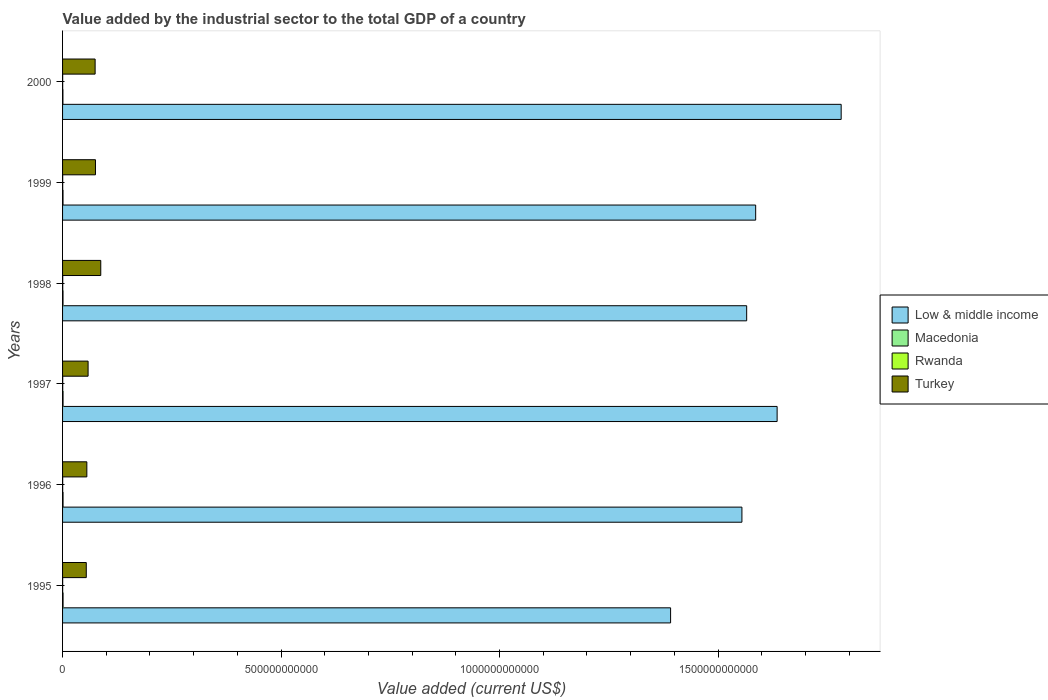Are the number of bars on each tick of the Y-axis equal?
Provide a short and direct response. Yes. In how many cases, is the number of bars for a given year not equal to the number of legend labels?
Your answer should be very brief. 0. What is the value added by the industrial sector to the total GDP in Turkey in 1999?
Provide a succinct answer. 7.53e+1. Across all years, what is the maximum value added by the industrial sector to the total GDP in Macedonia?
Your answer should be very brief. 1.13e+09. Across all years, what is the minimum value added by the industrial sector to the total GDP in Macedonia?
Offer a very short reply. 8.08e+08. In which year was the value added by the industrial sector to the total GDP in Turkey maximum?
Give a very brief answer. 1998. In which year was the value added by the industrial sector to the total GDP in Macedonia minimum?
Ensure brevity in your answer.  2000. What is the total value added by the industrial sector to the total GDP in Low & middle income in the graph?
Ensure brevity in your answer.  9.52e+12. What is the difference between the value added by the industrial sector to the total GDP in Low & middle income in 1998 and that in 2000?
Make the answer very short. -2.16e+11. What is the difference between the value added by the industrial sector to the total GDP in Rwanda in 1998 and the value added by the industrial sector to the total GDP in Low & middle income in 1999?
Your answer should be compact. -1.59e+12. What is the average value added by the industrial sector to the total GDP in Low & middle income per year?
Ensure brevity in your answer.  1.59e+12. In the year 1996, what is the difference between the value added by the industrial sector to the total GDP in Rwanda and value added by the industrial sector to the total GDP in Low & middle income?
Give a very brief answer. -1.55e+12. What is the ratio of the value added by the industrial sector to the total GDP in Low & middle income in 1996 to that in 1999?
Your response must be concise. 0.98. Is the value added by the industrial sector to the total GDP in Macedonia in 1998 less than that in 1999?
Offer a terse response. No. What is the difference between the highest and the second highest value added by the industrial sector to the total GDP in Rwanda?
Ensure brevity in your answer.  2.75e+07. What is the difference between the highest and the lowest value added by the industrial sector to the total GDP in Turkey?
Give a very brief answer. 3.31e+1. In how many years, is the value added by the industrial sector to the total GDP in Turkey greater than the average value added by the industrial sector to the total GDP in Turkey taken over all years?
Make the answer very short. 3. Is the sum of the value added by the industrial sector to the total GDP in Turkey in 1997 and 1998 greater than the maximum value added by the industrial sector to the total GDP in Macedonia across all years?
Your answer should be very brief. Yes. Is it the case that in every year, the sum of the value added by the industrial sector to the total GDP in Rwanda and value added by the industrial sector to the total GDP in Macedonia is greater than the sum of value added by the industrial sector to the total GDP in Low & middle income and value added by the industrial sector to the total GDP in Turkey?
Provide a succinct answer. No. What does the 4th bar from the top in 1996 represents?
Your response must be concise. Low & middle income. What does the 1st bar from the bottom in 1995 represents?
Offer a very short reply. Low & middle income. How many bars are there?
Give a very brief answer. 24. What is the difference between two consecutive major ticks on the X-axis?
Offer a terse response. 5.00e+11. Does the graph contain any zero values?
Make the answer very short. No. Does the graph contain grids?
Your response must be concise. No. How are the legend labels stacked?
Ensure brevity in your answer.  Vertical. What is the title of the graph?
Give a very brief answer. Value added by the industrial sector to the total GDP of a country. What is the label or title of the X-axis?
Give a very brief answer. Value added (current US$). What is the label or title of the Y-axis?
Your answer should be compact. Years. What is the Value added (current US$) in Low & middle income in 1995?
Provide a short and direct response. 1.39e+12. What is the Value added (current US$) in Macedonia in 1995?
Ensure brevity in your answer.  1.13e+09. What is the Value added (current US$) in Rwanda in 1995?
Your answer should be very brief. 2.07e+08. What is the Value added (current US$) of Turkey in 1995?
Give a very brief answer. 5.43e+1. What is the Value added (current US$) of Low & middle income in 1996?
Ensure brevity in your answer.  1.55e+12. What is the Value added (current US$) in Macedonia in 1996?
Your response must be concise. 1.11e+09. What is the Value added (current US$) in Rwanda in 1996?
Give a very brief answer. 2.50e+08. What is the Value added (current US$) of Turkey in 1996?
Give a very brief answer. 5.56e+1. What is the Value added (current US$) in Low & middle income in 1997?
Provide a short and direct response. 1.64e+12. What is the Value added (current US$) of Macedonia in 1997?
Make the answer very short. 1.11e+09. What is the Value added (current US$) of Rwanda in 1997?
Your answer should be very brief. 3.45e+08. What is the Value added (current US$) of Turkey in 1997?
Your answer should be compact. 5.84e+1. What is the Value added (current US$) in Low & middle income in 1998?
Provide a succinct answer. 1.57e+12. What is the Value added (current US$) of Macedonia in 1998?
Your answer should be compact. 1.04e+09. What is the Value added (current US$) of Rwanda in 1998?
Ensure brevity in your answer.  3.72e+08. What is the Value added (current US$) of Turkey in 1998?
Provide a short and direct response. 8.74e+1. What is the Value added (current US$) of Low & middle income in 1999?
Provide a short and direct response. 1.59e+12. What is the Value added (current US$) in Macedonia in 1999?
Ensure brevity in your answer.  1.03e+09. What is the Value added (current US$) of Rwanda in 1999?
Provide a short and direct response. 2.64e+08. What is the Value added (current US$) in Turkey in 1999?
Your response must be concise. 7.53e+1. What is the Value added (current US$) of Low & middle income in 2000?
Keep it short and to the point. 1.78e+12. What is the Value added (current US$) in Macedonia in 2000?
Keep it short and to the point. 8.08e+08. What is the Value added (current US$) of Rwanda in 2000?
Ensure brevity in your answer.  2.36e+08. What is the Value added (current US$) in Turkey in 2000?
Provide a short and direct response. 7.45e+1. Across all years, what is the maximum Value added (current US$) in Low & middle income?
Offer a very short reply. 1.78e+12. Across all years, what is the maximum Value added (current US$) of Macedonia?
Offer a very short reply. 1.13e+09. Across all years, what is the maximum Value added (current US$) in Rwanda?
Your response must be concise. 3.72e+08. Across all years, what is the maximum Value added (current US$) in Turkey?
Offer a terse response. 8.74e+1. Across all years, what is the minimum Value added (current US$) of Low & middle income?
Keep it short and to the point. 1.39e+12. Across all years, what is the minimum Value added (current US$) in Macedonia?
Keep it short and to the point. 8.08e+08. Across all years, what is the minimum Value added (current US$) in Rwanda?
Give a very brief answer. 2.07e+08. Across all years, what is the minimum Value added (current US$) of Turkey?
Offer a very short reply. 5.43e+1. What is the total Value added (current US$) in Low & middle income in the graph?
Keep it short and to the point. 9.52e+12. What is the total Value added (current US$) in Macedonia in the graph?
Provide a succinct answer. 6.22e+09. What is the total Value added (current US$) in Rwanda in the graph?
Ensure brevity in your answer.  1.67e+09. What is the total Value added (current US$) in Turkey in the graph?
Provide a short and direct response. 4.05e+11. What is the difference between the Value added (current US$) of Low & middle income in 1995 and that in 1996?
Offer a terse response. -1.63e+11. What is the difference between the Value added (current US$) of Macedonia in 1995 and that in 1996?
Provide a succinct answer. 1.90e+07. What is the difference between the Value added (current US$) in Rwanda in 1995 and that in 1996?
Give a very brief answer. -4.34e+07. What is the difference between the Value added (current US$) of Turkey in 1995 and that in 1996?
Offer a very short reply. -1.29e+09. What is the difference between the Value added (current US$) of Low & middle income in 1995 and that in 1997?
Give a very brief answer. -2.44e+11. What is the difference between the Value added (current US$) of Macedonia in 1995 and that in 1997?
Ensure brevity in your answer.  1.87e+07. What is the difference between the Value added (current US$) of Rwanda in 1995 and that in 1997?
Keep it short and to the point. -1.38e+08. What is the difference between the Value added (current US$) of Turkey in 1995 and that in 1997?
Your response must be concise. -4.16e+09. What is the difference between the Value added (current US$) of Low & middle income in 1995 and that in 1998?
Provide a short and direct response. -1.74e+11. What is the difference between the Value added (current US$) of Macedonia in 1995 and that in 1998?
Make the answer very short. 8.43e+07. What is the difference between the Value added (current US$) in Rwanda in 1995 and that in 1998?
Ensure brevity in your answer.  -1.65e+08. What is the difference between the Value added (current US$) of Turkey in 1995 and that in 1998?
Offer a very short reply. -3.31e+1. What is the difference between the Value added (current US$) of Low & middle income in 1995 and that in 1999?
Give a very brief answer. -1.95e+11. What is the difference between the Value added (current US$) in Macedonia in 1995 and that in 1999?
Ensure brevity in your answer.  9.93e+07. What is the difference between the Value added (current US$) in Rwanda in 1995 and that in 1999?
Provide a short and direct response. -5.75e+07. What is the difference between the Value added (current US$) in Turkey in 1995 and that in 1999?
Offer a very short reply. -2.10e+1. What is the difference between the Value added (current US$) of Low & middle income in 1995 and that in 2000?
Your answer should be compact. -3.90e+11. What is the difference between the Value added (current US$) in Macedonia in 1995 and that in 2000?
Ensure brevity in your answer.  3.19e+08. What is the difference between the Value added (current US$) in Rwanda in 1995 and that in 2000?
Your answer should be compact. -2.90e+07. What is the difference between the Value added (current US$) of Turkey in 1995 and that in 2000?
Make the answer very short. -2.02e+1. What is the difference between the Value added (current US$) of Low & middle income in 1996 and that in 1997?
Your response must be concise. -8.06e+1. What is the difference between the Value added (current US$) in Macedonia in 1996 and that in 1997?
Keep it short and to the point. -2.72e+05. What is the difference between the Value added (current US$) of Rwanda in 1996 and that in 1997?
Give a very brief answer. -9.46e+07. What is the difference between the Value added (current US$) of Turkey in 1996 and that in 1997?
Ensure brevity in your answer.  -2.87e+09. What is the difference between the Value added (current US$) of Low & middle income in 1996 and that in 1998?
Your answer should be compact. -1.09e+1. What is the difference between the Value added (current US$) of Macedonia in 1996 and that in 1998?
Make the answer very short. 6.53e+07. What is the difference between the Value added (current US$) of Rwanda in 1996 and that in 1998?
Ensure brevity in your answer.  -1.22e+08. What is the difference between the Value added (current US$) in Turkey in 1996 and that in 1998?
Ensure brevity in your answer.  -3.18e+1. What is the difference between the Value added (current US$) in Low & middle income in 1996 and that in 1999?
Offer a terse response. -3.15e+1. What is the difference between the Value added (current US$) in Macedonia in 1996 and that in 1999?
Ensure brevity in your answer.  8.03e+07. What is the difference between the Value added (current US$) in Rwanda in 1996 and that in 1999?
Ensure brevity in your answer.  -1.40e+07. What is the difference between the Value added (current US$) in Turkey in 1996 and that in 1999?
Offer a very short reply. -1.97e+1. What is the difference between the Value added (current US$) of Low & middle income in 1996 and that in 2000?
Make the answer very short. -2.27e+11. What is the difference between the Value added (current US$) in Macedonia in 1996 and that in 2000?
Offer a very short reply. 3.00e+08. What is the difference between the Value added (current US$) of Rwanda in 1996 and that in 2000?
Provide a succinct answer. 1.44e+07. What is the difference between the Value added (current US$) of Turkey in 1996 and that in 2000?
Provide a succinct answer. -1.89e+1. What is the difference between the Value added (current US$) of Low & middle income in 1997 and that in 1998?
Provide a short and direct response. 6.97e+1. What is the difference between the Value added (current US$) in Macedonia in 1997 and that in 1998?
Provide a succinct answer. 6.56e+07. What is the difference between the Value added (current US$) in Rwanda in 1997 and that in 1998?
Your answer should be very brief. -2.75e+07. What is the difference between the Value added (current US$) of Turkey in 1997 and that in 1998?
Your response must be concise. -2.90e+1. What is the difference between the Value added (current US$) of Low & middle income in 1997 and that in 1999?
Ensure brevity in your answer.  4.91e+1. What is the difference between the Value added (current US$) in Macedonia in 1997 and that in 1999?
Provide a succinct answer. 8.06e+07. What is the difference between the Value added (current US$) of Rwanda in 1997 and that in 1999?
Your answer should be compact. 8.05e+07. What is the difference between the Value added (current US$) in Turkey in 1997 and that in 1999?
Your answer should be very brief. -1.69e+1. What is the difference between the Value added (current US$) in Low & middle income in 1997 and that in 2000?
Ensure brevity in your answer.  -1.47e+11. What is the difference between the Value added (current US$) of Macedonia in 1997 and that in 2000?
Your answer should be very brief. 3.01e+08. What is the difference between the Value added (current US$) of Rwanda in 1997 and that in 2000?
Your response must be concise. 1.09e+08. What is the difference between the Value added (current US$) of Turkey in 1997 and that in 2000?
Give a very brief answer. -1.61e+1. What is the difference between the Value added (current US$) of Low & middle income in 1998 and that in 1999?
Your answer should be compact. -2.06e+1. What is the difference between the Value added (current US$) of Macedonia in 1998 and that in 1999?
Give a very brief answer. 1.50e+07. What is the difference between the Value added (current US$) in Rwanda in 1998 and that in 1999?
Provide a short and direct response. 1.08e+08. What is the difference between the Value added (current US$) in Turkey in 1998 and that in 1999?
Your answer should be compact. 1.21e+1. What is the difference between the Value added (current US$) in Low & middle income in 1998 and that in 2000?
Your response must be concise. -2.16e+11. What is the difference between the Value added (current US$) in Macedonia in 1998 and that in 2000?
Provide a short and direct response. 2.35e+08. What is the difference between the Value added (current US$) of Rwanda in 1998 and that in 2000?
Your answer should be very brief. 1.36e+08. What is the difference between the Value added (current US$) in Turkey in 1998 and that in 2000?
Give a very brief answer. 1.29e+1. What is the difference between the Value added (current US$) of Low & middle income in 1999 and that in 2000?
Provide a short and direct response. -1.96e+11. What is the difference between the Value added (current US$) of Macedonia in 1999 and that in 2000?
Provide a short and direct response. 2.20e+08. What is the difference between the Value added (current US$) of Rwanda in 1999 and that in 2000?
Your answer should be very brief. 2.84e+07. What is the difference between the Value added (current US$) of Turkey in 1999 and that in 2000?
Offer a terse response. 8.05e+08. What is the difference between the Value added (current US$) of Low & middle income in 1995 and the Value added (current US$) of Macedonia in 1996?
Your answer should be very brief. 1.39e+12. What is the difference between the Value added (current US$) in Low & middle income in 1995 and the Value added (current US$) in Rwanda in 1996?
Offer a terse response. 1.39e+12. What is the difference between the Value added (current US$) of Low & middle income in 1995 and the Value added (current US$) of Turkey in 1996?
Provide a short and direct response. 1.34e+12. What is the difference between the Value added (current US$) of Macedonia in 1995 and the Value added (current US$) of Rwanda in 1996?
Keep it short and to the point. 8.77e+08. What is the difference between the Value added (current US$) in Macedonia in 1995 and the Value added (current US$) in Turkey in 1996?
Your answer should be compact. -5.44e+1. What is the difference between the Value added (current US$) in Rwanda in 1995 and the Value added (current US$) in Turkey in 1996?
Your answer should be very brief. -5.54e+1. What is the difference between the Value added (current US$) in Low & middle income in 1995 and the Value added (current US$) in Macedonia in 1997?
Ensure brevity in your answer.  1.39e+12. What is the difference between the Value added (current US$) of Low & middle income in 1995 and the Value added (current US$) of Rwanda in 1997?
Offer a terse response. 1.39e+12. What is the difference between the Value added (current US$) in Low & middle income in 1995 and the Value added (current US$) in Turkey in 1997?
Provide a short and direct response. 1.33e+12. What is the difference between the Value added (current US$) of Macedonia in 1995 and the Value added (current US$) of Rwanda in 1997?
Give a very brief answer. 7.82e+08. What is the difference between the Value added (current US$) of Macedonia in 1995 and the Value added (current US$) of Turkey in 1997?
Offer a terse response. -5.73e+1. What is the difference between the Value added (current US$) of Rwanda in 1995 and the Value added (current US$) of Turkey in 1997?
Your answer should be compact. -5.82e+1. What is the difference between the Value added (current US$) of Low & middle income in 1995 and the Value added (current US$) of Macedonia in 1998?
Provide a short and direct response. 1.39e+12. What is the difference between the Value added (current US$) in Low & middle income in 1995 and the Value added (current US$) in Rwanda in 1998?
Offer a terse response. 1.39e+12. What is the difference between the Value added (current US$) of Low & middle income in 1995 and the Value added (current US$) of Turkey in 1998?
Your response must be concise. 1.30e+12. What is the difference between the Value added (current US$) in Macedonia in 1995 and the Value added (current US$) in Rwanda in 1998?
Provide a succinct answer. 7.55e+08. What is the difference between the Value added (current US$) of Macedonia in 1995 and the Value added (current US$) of Turkey in 1998?
Offer a very short reply. -8.63e+1. What is the difference between the Value added (current US$) of Rwanda in 1995 and the Value added (current US$) of Turkey in 1998?
Your answer should be very brief. -8.72e+1. What is the difference between the Value added (current US$) in Low & middle income in 1995 and the Value added (current US$) in Macedonia in 1999?
Make the answer very short. 1.39e+12. What is the difference between the Value added (current US$) of Low & middle income in 1995 and the Value added (current US$) of Rwanda in 1999?
Your answer should be very brief. 1.39e+12. What is the difference between the Value added (current US$) in Low & middle income in 1995 and the Value added (current US$) in Turkey in 1999?
Provide a succinct answer. 1.32e+12. What is the difference between the Value added (current US$) in Macedonia in 1995 and the Value added (current US$) in Rwanda in 1999?
Ensure brevity in your answer.  8.63e+08. What is the difference between the Value added (current US$) in Macedonia in 1995 and the Value added (current US$) in Turkey in 1999?
Your answer should be compact. -7.42e+1. What is the difference between the Value added (current US$) in Rwanda in 1995 and the Value added (current US$) in Turkey in 1999?
Keep it short and to the point. -7.51e+1. What is the difference between the Value added (current US$) in Low & middle income in 1995 and the Value added (current US$) in Macedonia in 2000?
Make the answer very short. 1.39e+12. What is the difference between the Value added (current US$) in Low & middle income in 1995 and the Value added (current US$) in Rwanda in 2000?
Offer a very short reply. 1.39e+12. What is the difference between the Value added (current US$) in Low & middle income in 1995 and the Value added (current US$) in Turkey in 2000?
Keep it short and to the point. 1.32e+12. What is the difference between the Value added (current US$) of Macedonia in 1995 and the Value added (current US$) of Rwanda in 2000?
Keep it short and to the point. 8.91e+08. What is the difference between the Value added (current US$) of Macedonia in 1995 and the Value added (current US$) of Turkey in 2000?
Provide a short and direct response. -7.34e+1. What is the difference between the Value added (current US$) of Rwanda in 1995 and the Value added (current US$) of Turkey in 2000?
Offer a terse response. -7.43e+1. What is the difference between the Value added (current US$) of Low & middle income in 1996 and the Value added (current US$) of Macedonia in 1997?
Make the answer very short. 1.55e+12. What is the difference between the Value added (current US$) of Low & middle income in 1996 and the Value added (current US$) of Rwanda in 1997?
Keep it short and to the point. 1.55e+12. What is the difference between the Value added (current US$) in Low & middle income in 1996 and the Value added (current US$) in Turkey in 1997?
Give a very brief answer. 1.50e+12. What is the difference between the Value added (current US$) in Macedonia in 1996 and the Value added (current US$) in Rwanda in 1997?
Your answer should be compact. 7.63e+08. What is the difference between the Value added (current US$) in Macedonia in 1996 and the Value added (current US$) in Turkey in 1997?
Provide a succinct answer. -5.73e+1. What is the difference between the Value added (current US$) of Rwanda in 1996 and the Value added (current US$) of Turkey in 1997?
Ensure brevity in your answer.  -5.82e+1. What is the difference between the Value added (current US$) in Low & middle income in 1996 and the Value added (current US$) in Macedonia in 1998?
Provide a succinct answer. 1.55e+12. What is the difference between the Value added (current US$) of Low & middle income in 1996 and the Value added (current US$) of Rwanda in 1998?
Offer a very short reply. 1.55e+12. What is the difference between the Value added (current US$) in Low & middle income in 1996 and the Value added (current US$) in Turkey in 1998?
Ensure brevity in your answer.  1.47e+12. What is the difference between the Value added (current US$) of Macedonia in 1996 and the Value added (current US$) of Rwanda in 1998?
Give a very brief answer. 7.36e+08. What is the difference between the Value added (current US$) of Macedonia in 1996 and the Value added (current US$) of Turkey in 1998?
Make the answer very short. -8.63e+1. What is the difference between the Value added (current US$) of Rwanda in 1996 and the Value added (current US$) of Turkey in 1998?
Your answer should be compact. -8.72e+1. What is the difference between the Value added (current US$) in Low & middle income in 1996 and the Value added (current US$) in Macedonia in 1999?
Offer a very short reply. 1.55e+12. What is the difference between the Value added (current US$) in Low & middle income in 1996 and the Value added (current US$) in Rwanda in 1999?
Give a very brief answer. 1.55e+12. What is the difference between the Value added (current US$) in Low & middle income in 1996 and the Value added (current US$) in Turkey in 1999?
Keep it short and to the point. 1.48e+12. What is the difference between the Value added (current US$) in Macedonia in 1996 and the Value added (current US$) in Rwanda in 1999?
Your answer should be very brief. 8.44e+08. What is the difference between the Value added (current US$) in Macedonia in 1996 and the Value added (current US$) in Turkey in 1999?
Provide a succinct answer. -7.42e+1. What is the difference between the Value added (current US$) of Rwanda in 1996 and the Value added (current US$) of Turkey in 1999?
Make the answer very short. -7.51e+1. What is the difference between the Value added (current US$) in Low & middle income in 1996 and the Value added (current US$) in Macedonia in 2000?
Provide a short and direct response. 1.55e+12. What is the difference between the Value added (current US$) in Low & middle income in 1996 and the Value added (current US$) in Rwanda in 2000?
Provide a succinct answer. 1.55e+12. What is the difference between the Value added (current US$) in Low & middle income in 1996 and the Value added (current US$) in Turkey in 2000?
Offer a terse response. 1.48e+12. What is the difference between the Value added (current US$) in Macedonia in 1996 and the Value added (current US$) in Rwanda in 2000?
Your answer should be compact. 8.72e+08. What is the difference between the Value added (current US$) in Macedonia in 1996 and the Value added (current US$) in Turkey in 2000?
Provide a short and direct response. -7.34e+1. What is the difference between the Value added (current US$) in Rwanda in 1996 and the Value added (current US$) in Turkey in 2000?
Make the answer very short. -7.43e+1. What is the difference between the Value added (current US$) in Low & middle income in 1997 and the Value added (current US$) in Macedonia in 1998?
Offer a terse response. 1.63e+12. What is the difference between the Value added (current US$) of Low & middle income in 1997 and the Value added (current US$) of Rwanda in 1998?
Provide a short and direct response. 1.63e+12. What is the difference between the Value added (current US$) in Low & middle income in 1997 and the Value added (current US$) in Turkey in 1998?
Your answer should be very brief. 1.55e+12. What is the difference between the Value added (current US$) in Macedonia in 1997 and the Value added (current US$) in Rwanda in 1998?
Your response must be concise. 7.36e+08. What is the difference between the Value added (current US$) of Macedonia in 1997 and the Value added (current US$) of Turkey in 1998?
Make the answer very short. -8.63e+1. What is the difference between the Value added (current US$) in Rwanda in 1997 and the Value added (current US$) in Turkey in 1998?
Your answer should be compact. -8.71e+1. What is the difference between the Value added (current US$) in Low & middle income in 1997 and the Value added (current US$) in Macedonia in 1999?
Your response must be concise. 1.63e+12. What is the difference between the Value added (current US$) in Low & middle income in 1997 and the Value added (current US$) in Rwanda in 1999?
Your answer should be compact. 1.64e+12. What is the difference between the Value added (current US$) in Low & middle income in 1997 and the Value added (current US$) in Turkey in 1999?
Offer a very short reply. 1.56e+12. What is the difference between the Value added (current US$) of Macedonia in 1997 and the Value added (current US$) of Rwanda in 1999?
Give a very brief answer. 8.44e+08. What is the difference between the Value added (current US$) in Macedonia in 1997 and the Value added (current US$) in Turkey in 1999?
Give a very brief answer. -7.42e+1. What is the difference between the Value added (current US$) in Rwanda in 1997 and the Value added (current US$) in Turkey in 1999?
Your response must be concise. -7.50e+1. What is the difference between the Value added (current US$) of Low & middle income in 1997 and the Value added (current US$) of Macedonia in 2000?
Ensure brevity in your answer.  1.63e+12. What is the difference between the Value added (current US$) of Low & middle income in 1997 and the Value added (current US$) of Rwanda in 2000?
Give a very brief answer. 1.64e+12. What is the difference between the Value added (current US$) in Low & middle income in 1997 and the Value added (current US$) in Turkey in 2000?
Give a very brief answer. 1.56e+12. What is the difference between the Value added (current US$) in Macedonia in 1997 and the Value added (current US$) in Rwanda in 2000?
Offer a terse response. 8.72e+08. What is the difference between the Value added (current US$) of Macedonia in 1997 and the Value added (current US$) of Turkey in 2000?
Ensure brevity in your answer.  -7.34e+1. What is the difference between the Value added (current US$) in Rwanda in 1997 and the Value added (current US$) in Turkey in 2000?
Offer a very short reply. -7.42e+1. What is the difference between the Value added (current US$) of Low & middle income in 1998 and the Value added (current US$) of Macedonia in 1999?
Provide a short and direct response. 1.56e+12. What is the difference between the Value added (current US$) of Low & middle income in 1998 and the Value added (current US$) of Rwanda in 1999?
Provide a succinct answer. 1.57e+12. What is the difference between the Value added (current US$) in Low & middle income in 1998 and the Value added (current US$) in Turkey in 1999?
Keep it short and to the point. 1.49e+12. What is the difference between the Value added (current US$) of Macedonia in 1998 and the Value added (current US$) of Rwanda in 1999?
Provide a succinct answer. 7.78e+08. What is the difference between the Value added (current US$) of Macedonia in 1998 and the Value added (current US$) of Turkey in 1999?
Make the answer very short. -7.43e+1. What is the difference between the Value added (current US$) of Rwanda in 1998 and the Value added (current US$) of Turkey in 1999?
Your response must be concise. -7.49e+1. What is the difference between the Value added (current US$) in Low & middle income in 1998 and the Value added (current US$) in Macedonia in 2000?
Make the answer very short. 1.56e+12. What is the difference between the Value added (current US$) in Low & middle income in 1998 and the Value added (current US$) in Rwanda in 2000?
Keep it short and to the point. 1.57e+12. What is the difference between the Value added (current US$) in Low & middle income in 1998 and the Value added (current US$) in Turkey in 2000?
Offer a very short reply. 1.49e+12. What is the difference between the Value added (current US$) of Macedonia in 1998 and the Value added (current US$) of Rwanda in 2000?
Give a very brief answer. 8.07e+08. What is the difference between the Value added (current US$) in Macedonia in 1998 and the Value added (current US$) in Turkey in 2000?
Your answer should be compact. -7.35e+1. What is the difference between the Value added (current US$) of Rwanda in 1998 and the Value added (current US$) of Turkey in 2000?
Provide a succinct answer. -7.41e+1. What is the difference between the Value added (current US$) in Low & middle income in 1999 and the Value added (current US$) in Macedonia in 2000?
Your answer should be compact. 1.59e+12. What is the difference between the Value added (current US$) in Low & middle income in 1999 and the Value added (current US$) in Rwanda in 2000?
Make the answer very short. 1.59e+12. What is the difference between the Value added (current US$) of Low & middle income in 1999 and the Value added (current US$) of Turkey in 2000?
Your response must be concise. 1.51e+12. What is the difference between the Value added (current US$) in Macedonia in 1999 and the Value added (current US$) in Rwanda in 2000?
Give a very brief answer. 7.92e+08. What is the difference between the Value added (current US$) in Macedonia in 1999 and the Value added (current US$) in Turkey in 2000?
Your answer should be very brief. -7.35e+1. What is the difference between the Value added (current US$) in Rwanda in 1999 and the Value added (current US$) in Turkey in 2000?
Make the answer very short. -7.42e+1. What is the average Value added (current US$) in Low & middle income per year?
Provide a succinct answer. 1.59e+12. What is the average Value added (current US$) of Macedonia per year?
Provide a short and direct response. 1.04e+09. What is the average Value added (current US$) of Rwanda per year?
Your response must be concise. 2.79e+08. What is the average Value added (current US$) in Turkey per year?
Provide a short and direct response. 6.76e+1. In the year 1995, what is the difference between the Value added (current US$) in Low & middle income and Value added (current US$) in Macedonia?
Offer a terse response. 1.39e+12. In the year 1995, what is the difference between the Value added (current US$) of Low & middle income and Value added (current US$) of Rwanda?
Your answer should be compact. 1.39e+12. In the year 1995, what is the difference between the Value added (current US$) in Low & middle income and Value added (current US$) in Turkey?
Give a very brief answer. 1.34e+12. In the year 1995, what is the difference between the Value added (current US$) in Macedonia and Value added (current US$) in Rwanda?
Your answer should be compact. 9.20e+08. In the year 1995, what is the difference between the Value added (current US$) in Macedonia and Value added (current US$) in Turkey?
Provide a short and direct response. -5.31e+1. In the year 1995, what is the difference between the Value added (current US$) of Rwanda and Value added (current US$) of Turkey?
Offer a very short reply. -5.41e+1. In the year 1996, what is the difference between the Value added (current US$) of Low & middle income and Value added (current US$) of Macedonia?
Keep it short and to the point. 1.55e+12. In the year 1996, what is the difference between the Value added (current US$) of Low & middle income and Value added (current US$) of Rwanda?
Ensure brevity in your answer.  1.55e+12. In the year 1996, what is the difference between the Value added (current US$) in Low & middle income and Value added (current US$) in Turkey?
Your answer should be compact. 1.50e+12. In the year 1996, what is the difference between the Value added (current US$) of Macedonia and Value added (current US$) of Rwanda?
Your answer should be very brief. 8.58e+08. In the year 1996, what is the difference between the Value added (current US$) of Macedonia and Value added (current US$) of Turkey?
Keep it short and to the point. -5.45e+1. In the year 1996, what is the difference between the Value added (current US$) in Rwanda and Value added (current US$) in Turkey?
Make the answer very short. -5.53e+1. In the year 1997, what is the difference between the Value added (current US$) of Low & middle income and Value added (current US$) of Macedonia?
Offer a very short reply. 1.63e+12. In the year 1997, what is the difference between the Value added (current US$) in Low & middle income and Value added (current US$) in Rwanda?
Your answer should be very brief. 1.63e+12. In the year 1997, what is the difference between the Value added (current US$) in Low & middle income and Value added (current US$) in Turkey?
Offer a very short reply. 1.58e+12. In the year 1997, what is the difference between the Value added (current US$) of Macedonia and Value added (current US$) of Rwanda?
Give a very brief answer. 7.64e+08. In the year 1997, what is the difference between the Value added (current US$) in Macedonia and Value added (current US$) in Turkey?
Keep it short and to the point. -5.73e+1. In the year 1997, what is the difference between the Value added (current US$) of Rwanda and Value added (current US$) of Turkey?
Keep it short and to the point. -5.81e+1. In the year 1998, what is the difference between the Value added (current US$) of Low & middle income and Value added (current US$) of Macedonia?
Give a very brief answer. 1.56e+12. In the year 1998, what is the difference between the Value added (current US$) in Low & middle income and Value added (current US$) in Rwanda?
Provide a short and direct response. 1.57e+12. In the year 1998, what is the difference between the Value added (current US$) in Low & middle income and Value added (current US$) in Turkey?
Your answer should be very brief. 1.48e+12. In the year 1998, what is the difference between the Value added (current US$) in Macedonia and Value added (current US$) in Rwanda?
Provide a succinct answer. 6.70e+08. In the year 1998, what is the difference between the Value added (current US$) of Macedonia and Value added (current US$) of Turkey?
Your answer should be compact. -8.64e+1. In the year 1998, what is the difference between the Value added (current US$) in Rwanda and Value added (current US$) in Turkey?
Ensure brevity in your answer.  -8.70e+1. In the year 1999, what is the difference between the Value added (current US$) of Low & middle income and Value added (current US$) of Macedonia?
Ensure brevity in your answer.  1.59e+12. In the year 1999, what is the difference between the Value added (current US$) of Low & middle income and Value added (current US$) of Rwanda?
Your answer should be very brief. 1.59e+12. In the year 1999, what is the difference between the Value added (current US$) of Low & middle income and Value added (current US$) of Turkey?
Your answer should be compact. 1.51e+12. In the year 1999, what is the difference between the Value added (current US$) in Macedonia and Value added (current US$) in Rwanda?
Your answer should be compact. 7.63e+08. In the year 1999, what is the difference between the Value added (current US$) in Macedonia and Value added (current US$) in Turkey?
Ensure brevity in your answer.  -7.43e+1. In the year 1999, what is the difference between the Value added (current US$) of Rwanda and Value added (current US$) of Turkey?
Your response must be concise. -7.50e+1. In the year 2000, what is the difference between the Value added (current US$) of Low & middle income and Value added (current US$) of Macedonia?
Make the answer very short. 1.78e+12. In the year 2000, what is the difference between the Value added (current US$) of Low & middle income and Value added (current US$) of Rwanda?
Ensure brevity in your answer.  1.78e+12. In the year 2000, what is the difference between the Value added (current US$) in Low & middle income and Value added (current US$) in Turkey?
Your response must be concise. 1.71e+12. In the year 2000, what is the difference between the Value added (current US$) of Macedonia and Value added (current US$) of Rwanda?
Offer a very short reply. 5.72e+08. In the year 2000, what is the difference between the Value added (current US$) of Macedonia and Value added (current US$) of Turkey?
Provide a short and direct response. -7.37e+1. In the year 2000, what is the difference between the Value added (current US$) of Rwanda and Value added (current US$) of Turkey?
Provide a succinct answer. -7.43e+1. What is the ratio of the Value added (current US$) in Low & middle income in 1995 to that in 1996?
Provide a short and direct response. 0.9. What is the ratio of the Value added (current US$) in Macedonia in 1995 to that in 1996?
Give a very brief answer. 1.02. What is the ratio of the Value added (current US$) in Rwanda in 1995 to that in 1996?
Provide a short and direct response. 0.83. What is the ratio of the Value added (current US$) in Turkey in 1995 to that in 1996?
Ensure brevity in your answer.  0.98. What is the ratio of the Value added (current US$) of Low & middle income in 1995 to that in 1997?
Keep it short and to the point. 0.85. What is the ratio of the Value added (current US$) of Macedonia in 1995 to that in 1997?
Ensure brevity in your answer.  1.02. What is the ratio of the Value added (current US$) of Rwanda in 1995 to that in 1997?
Make the answer very short. 0.6. What is the ratio of the Value added (current US$) of Turkey in 1995 to that in 1997?
Provide a succinct answer. 0.93. What is the ratio of the Value added (current US$) of Low & middle income in 1995 to that in 1998?
Your answer should be compact. 0.89. What is the ratio of the Value added (current US$) of Macedonia in 1995 to that in 1998?
Ensure brevity in your answer.  1.08. What is the ratio of the Value added (current US$) of Rwanda in 1995 to that in 1998?
Your answer should be very brief. 0.56. What is the ratio of the Value added (current US$) in Turkey in 1995 to that in 1998?
Keep it short and to the point. 0.62. What is the ratio of the Value added (current US$) of Low & middle income in 1995 to that in 1999?
Ensure brevity in your answer.  0.88. What is the ratio of the Value added (current US$) of Macedonia in 1995 to that in 1999?
Provide a short and direct response. 1.1. What is the ratio of the Value added (current US$) in Rwanda in 1995 to that in 1999?
Make the answer very short. 0.78. What is the ratio of the Value added (current US$) of Turkey in 1995 to that in 1999?
Your answer should be very brief. 0.72. What is the ratio of the Value added (current US$) of Low & middle income in 1995 to that in 2000?
Give a very brief answer. 0.78. What is the ratio of the Value added (current US$) of Macedonia in 1995 to that in 2000?
Keep it short and to the point. 1.4. What is the ratio of the Value added (current US$) in Rwanda in 1995 to that in 2000?
Offer a very short reply. 0.88. What is the ratio of the Value added (current US$) of Turkey in 1995 to that in 2000?
Your answer should be compact. 0.73. What is the ratio of the Value added (current US$) in Low & middle income in 1996 to that in 1997?
Your response must be concise. 0.95. What is the ratio of the Value added (current US$) in Macedonia in 1996 to that in 1997?
Provide a succinct answer. 1. What is the ratio of the Value added (current US$) of Rwanda in 1996 to that in 1997?
Give a very brief answer. 0.73. What is the ratio of the Value added (current US$) in Turkey in 1996 to that in 1997?
Provide a short and direct response. 0.95. What is the ratio of the Value added (current US$) in Low & middle income in 1996 to that in 1998?
Make the answer very short. 0.99. What is the ratio of the Value added (current US$) of Macedonia in 1996 to that in 1998?
Your answer should be very brief. 1.06. What is the ratio of the Value added (current US$) of Rwanda in 1996 to that in 1998?
Your answer should be very brief. 0.67. What is the ratio of the Value added (current US$) of Turkey in 1996 to that in 1998?
Offer a terse response. 0.64. What is the ratio of the Value added (current US$) in Low & middle income in 1996 to that in 1999?
Provide a short and direct response. 0.98. What is the ratio of the Value added (current US$) in Macedonia in 1996 to that in 1999?
Your response must be concise. 1.08. What is the ratio of the Value added (current US$) in Rwanda in 1996 to that in 1999?
Make the answer very short. 0.95. What is the ratio of the Value added (current US$) of Turkey in 1996 to that in 1999?
Provide a succinct answer. 0.74. What is the ratio of the Value added (current US$) in Low & middle income in 1996 to that in 2000?
Make the answer very short. 0.87. What is the ratio of the Value added (current US$) in Macedonia in 1996 to that in 2000?
Give a very brief answer. 1.37. What is the ratio of the Value added (current US$) of Rwanda in 1996 to that in 2000?
Provide a short and direct response. 1.06. What is the ratio of the Value added (current US$) of Turkey in 1996 to that in 2000?
Keep it short and to the point. 0.75. What is the ratio of the Value added (current US$) in Low & middle income in 1997 to that in 1998?
Your answer should be compact. 1.04. What is the ratio of the Value added (current US$) in Macedonia in 1997 to that in 1998?
Make the answer very short. 1.06. What is the ratio of the Value added (current US$) in Rwanda in 1997 to that in 1998?
Ensure brevity in your answer.  0.93. What is the ratio of the Value added (current US$) of Turkey in 1997 to that in 1998?
Your answer should be very brief. 0.67. What is the ratio of the Value added (current US$) of Low & middle income in 1997 to that in 1999?
Provide a short and direct response. 1.03. What is the ratio of the Value added (current US$) of Macedonia in 1997 to that in 1999?
Your answer should be compact. 1.08. What is the ratio of the Value added (current US$) of Rwanda in 1997 to that in 1999?
Ensure brevity in your answer.  1.3. What is the ratio of the Value added (current US$) in Turkey in 1997 to that in 1999?
Your response must be concise. 0.78. What is the ratio of the Value added (current US$) in Low & middle income in 1997 to that in 2000?
Your response must be concise. 0.92. What is the ratio of the Value added (current US$) of Macedonia in 1997 to that in 2000?
Your answer should be very brief. 1.37. What is the ratio of the Value added (current US$) in Rwanda in 1997 to that in 2000?
Make the answer very short. 1.46. What is the ratio of the Value added (current US$) of Turkey in 1997 to that in 2000?
Your answer should be compact. 0.78. What is the ratio of the Value added (current US$) in Low & middle income in 1998 to that in 1999?
Provide a short and direct response. 0.99. What is the ratio of the Value added (current US$) of Macedonia in 1998 to that in 1999?
Ensure brevity in your answer.  1.01. What is the ratio of the Value added (current US$) of Rwanda in 1998 to that in 1999?
Your response must be concise. 1.41. What is the ratio of the Value added (current US$) in Turkey in 1998 to that in 1999?
Ensure brevity in your answer.  1.16. What is the ratio of the Value added (current US$) in Low & middle income in 1998 to that in 2000?
Your answer should be very brief. 0.88. What is the ratio of the Value added (current US$) of Macedonia in 1998 to that in 2000?
Give a very brief answer. 1.29. What is the ratio of the Value added (current US$) in Rwanda in 1998 to that in 2000?
Your response must be concise. 1.58. What is the ratio of the Value added (current US$) of Turkey in 1998 to that in 2000?
Provide a short and direct response. 1.17. What is the ratio of the Value added (current US$) of Low & middle income in 1999 to that in 2000?
Provide a succinct answer. 0.89. What is the ratio of the Value added (current US$) in Macedonia in 1999 to that in 2000?
Make the answer very short. 1.27. What is the ratio of the Value added (current US$) of Rwanda in 1999 to that in 2000?
Provide a short and direct response. 1.12. What is the ratio of the Value added (current US$) in Turkey in 1999 to that in 2000?
Your answer should be very brief. 1.01. What is the difference between the highest and the second highest Value added (current US$) of Low & middle income?
Provide a short and direct response. 1.47e+11. What is the difference between the highest and the second highest Value added (current US$) of Macedonia?
Offer a very short reply. 1.87e+07. What is the difference between the highest and the second highest Value added (current US$) in Rwanda?
Offer a terse response. 2.75e+07. What is the difference between the highest and the second highest Value added (current US$) in Turkey?
Ensure brevity in your answer.  1.21e+1. What is the difference between the highest and the lowest Value added (current US$) of Low & middle income?
Your response must be concise. 3.90e+11. What is the difference between the highest and the lowest Value added (current US$) of Macedonia?
Provide a succinct answer. 3.19e+08. What is the difference between the highest and the lowest Value added (current US$) in Rwanda?
Provide a short and direct response. 1.65e+08. What is the difference between the highest and the lowest Value added (current US$) of Turkey?
Your response must be concise. 3.31e+1. 